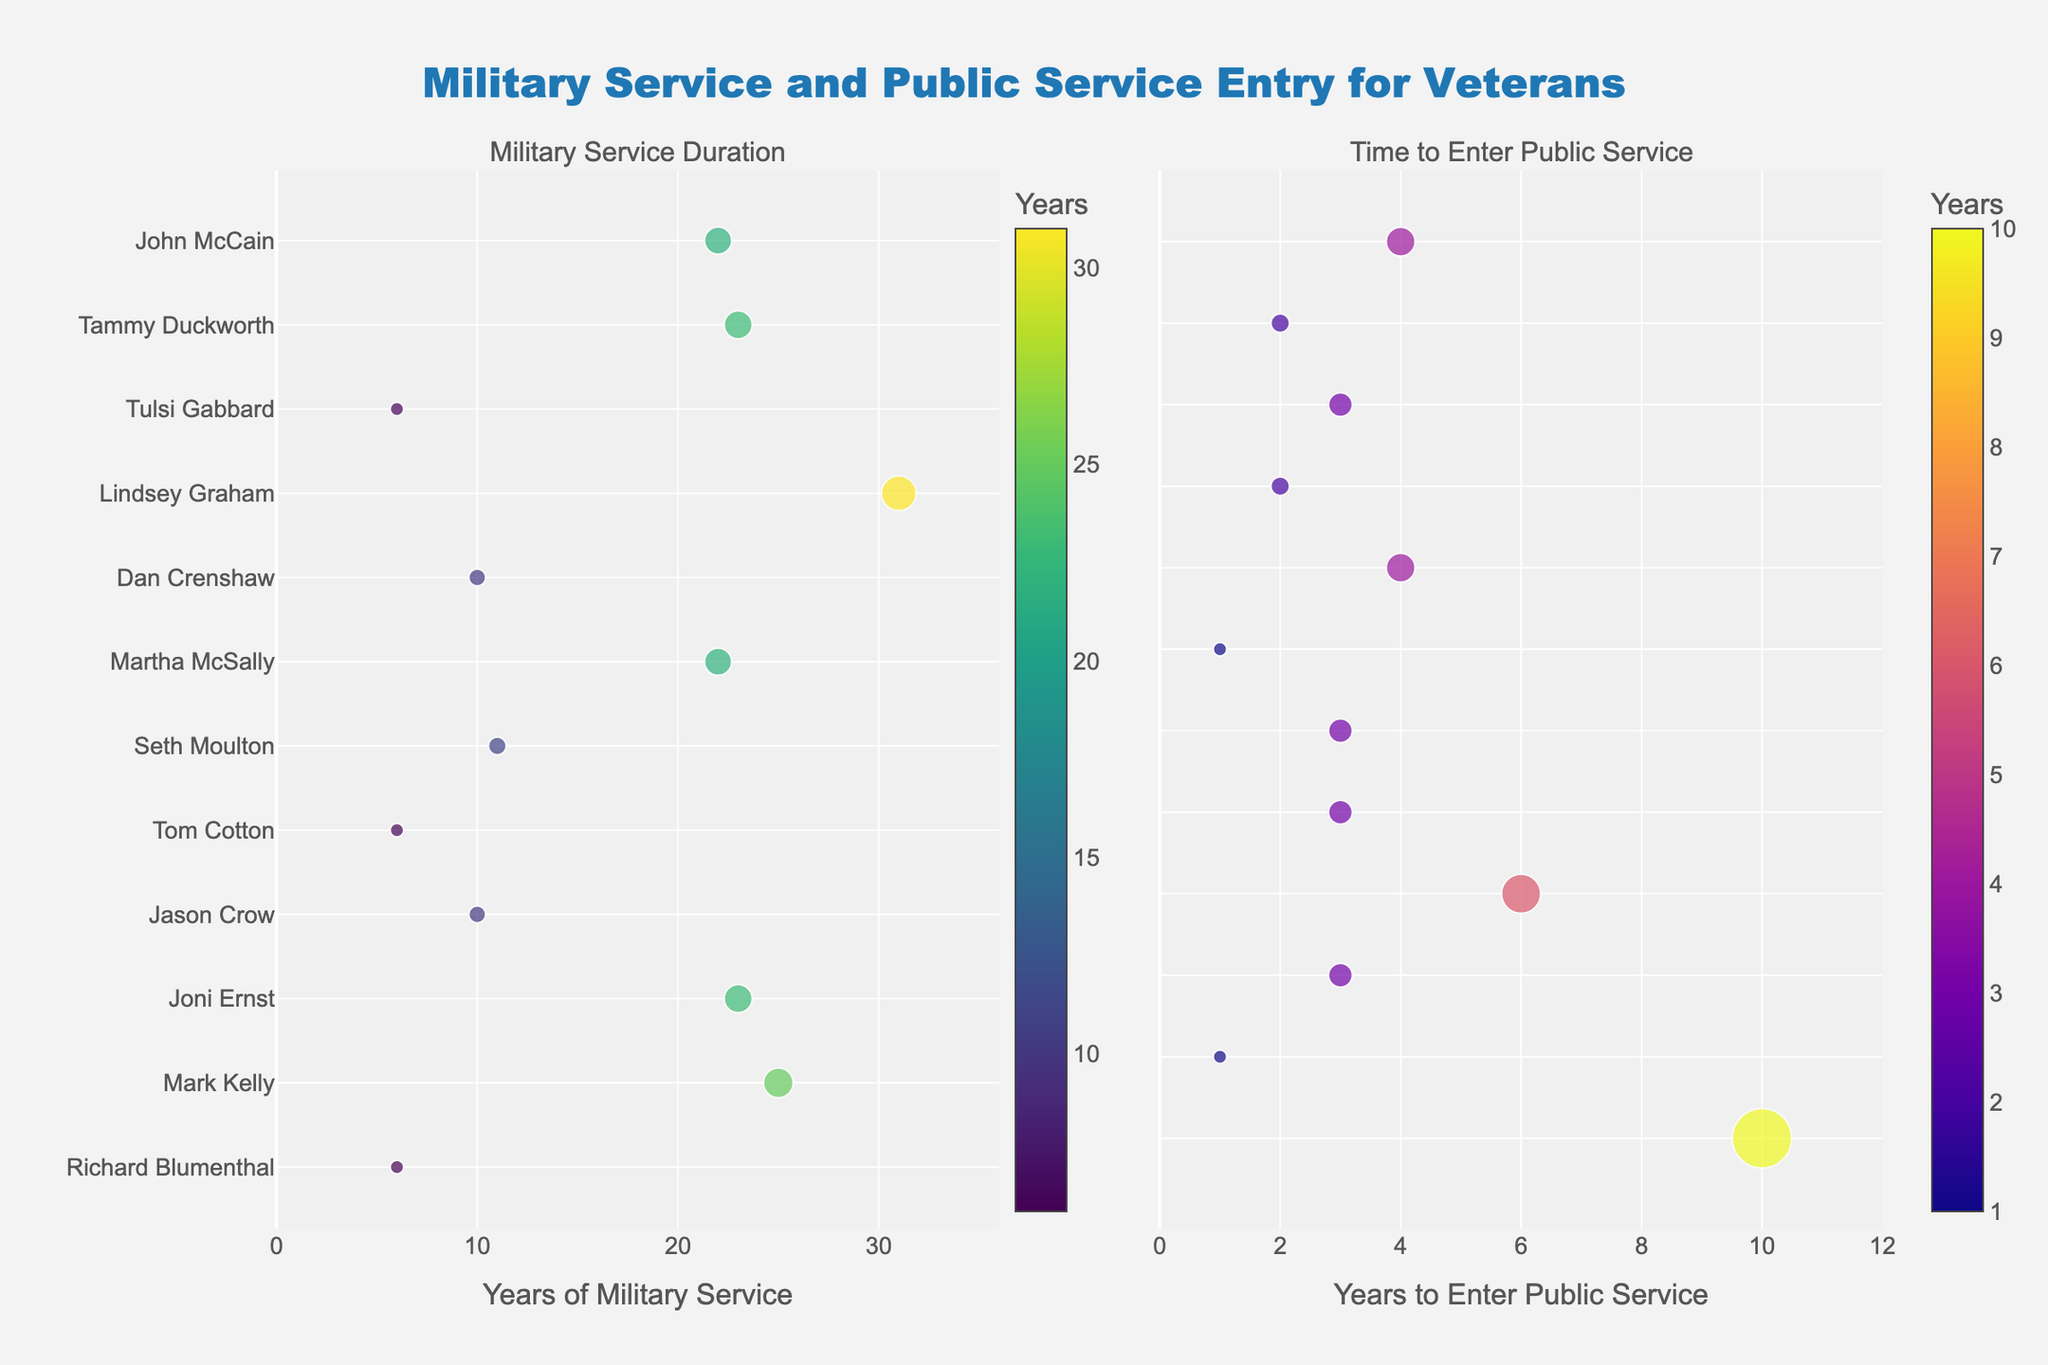What's the title of the figure? The title of the figure is located at the top center and it reads "Military Service and Public Service Entry for Veterans".
Answer: Military Service and Public Service Entry for Veterans How many years of military service does Lindsey Graham have? Refer to the left subplot and look for Lindsey Graham on the vertical axis. Follow the corresponding marker horizontally to read the value from the color bar.
Answer: 31 Which veteran has the longest time to enter public service? In the right subplot, identify the marker with the maximum value on the horizontal axis, which corresponds to the longest time to enter public service. The veteran for this marker is Richard Blumenthal.
Answer: Richard Blumenthal On average, did veterans with shorter military service take more or less time to enter public service compared to those with longer military service? Compare the horizontal positions of markers in the right subplot for veterans with short service (like Richard Blumenthal, 6 years) and long service (like Lindsey Graham, 31 years). Shorter service veterans like Richard Blumenthal took more time compared to those like Lindsey Graham.
Answer: More time What are the average years of military service for the veterans who took exactly 3 years to enter public service? In the right subplot, find the markers aligned with "3" on the horizontal axis. Then cross-reference these veterans (Tulsi Gabbard, Seth Moulton, Tom Cotton, Joni Ernst) with the left subplot to get their military service years. Calculate the average of those values (6, 11, 6, 23).
Answer: 11.5 Who took the shortest time to enter public service and how many years did they serve in the military? Identify the veteran with the marker closest to zero on the x-axis of the right subplot (Martha McSally) and refer to their military service years in the left subplot.
Answer: Martha McSally, 22 Of the veterans with a military service duration greater than 20 years, who entered public service the quickest? Filter veterans from the left subplot for those with more than 20 years of service (John McCain, Tammy Duckworth, Lindsey Graham, Martha McSally, Joni Ernst, Mark Kelly), then in the right subplot check who has the smallest value on the horizontal axis (Mark Kelly).
Answer: Mark Kelly 